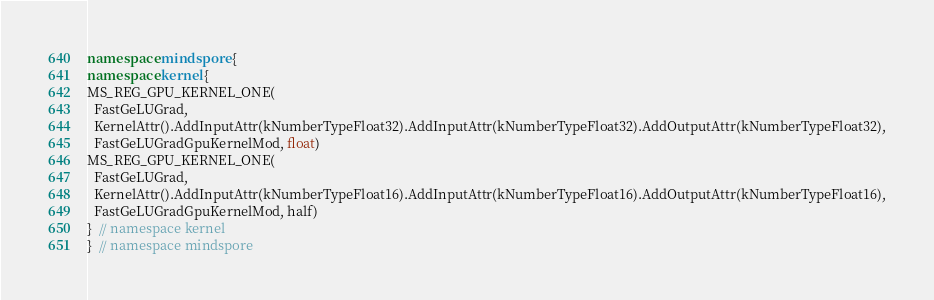<code> <loc_0><loc_0><loc_500><loc_500><_C++_>namespace mindspore {
namespace kernel {
MS_REG_GPU_KERNEL_ONE(
  FastGeLUGrad,
  KernelAttr().AddInputAttr(kNumberTypeFloat32).AddInputAttr(kNumberTypeFloat32).AddOutputAttr(kNumberTypeFloat32),
  FastGeLUGradGpuKernelMod, float)
MS_REG_GPU_KERNEL_ONE(
  FastGeLUGrad,
  KernelAttr().AddInputAttr(kNumberTypeFloat16).AddInputAttr(kNumberTypeFloat16).AddOutputAttr(kNumberTypeFloat16),
  FastGeLUGradGpuKernelMod, half)
}  // namespace kernel
}  // namespace mindspore
</code> 